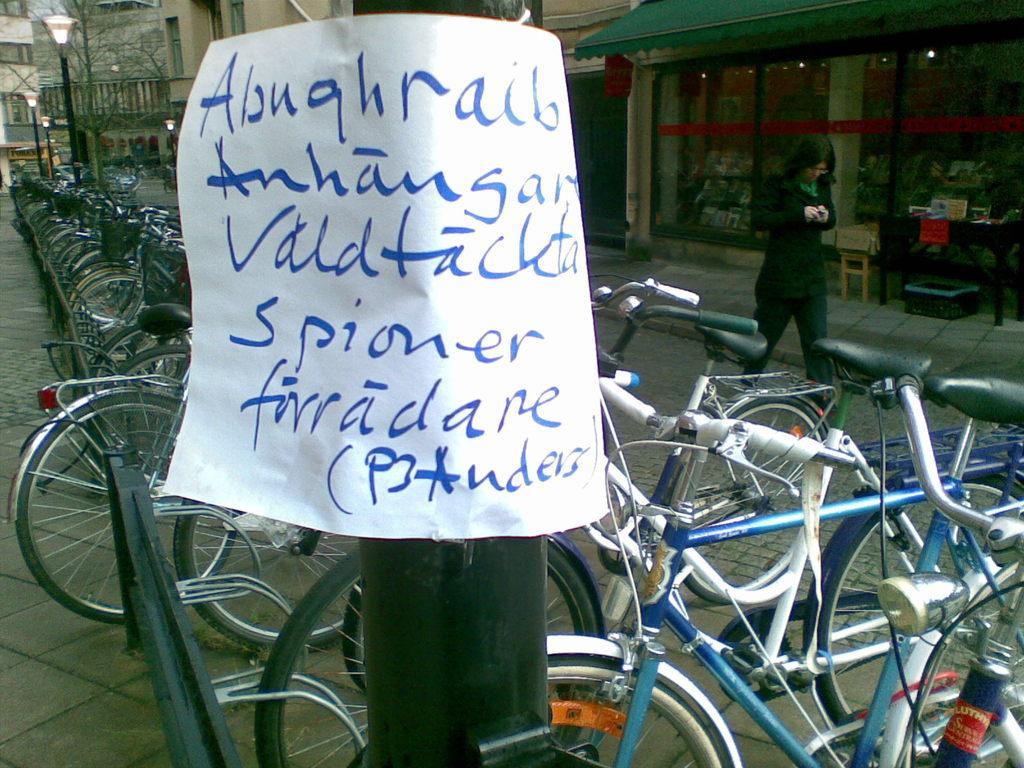Can you describe this image briefly? In this image, there is a black color pole, on that pole there is a white color poster, there are some bicycle kept in a queue, at the right side there is a person walking and there is a shop. 